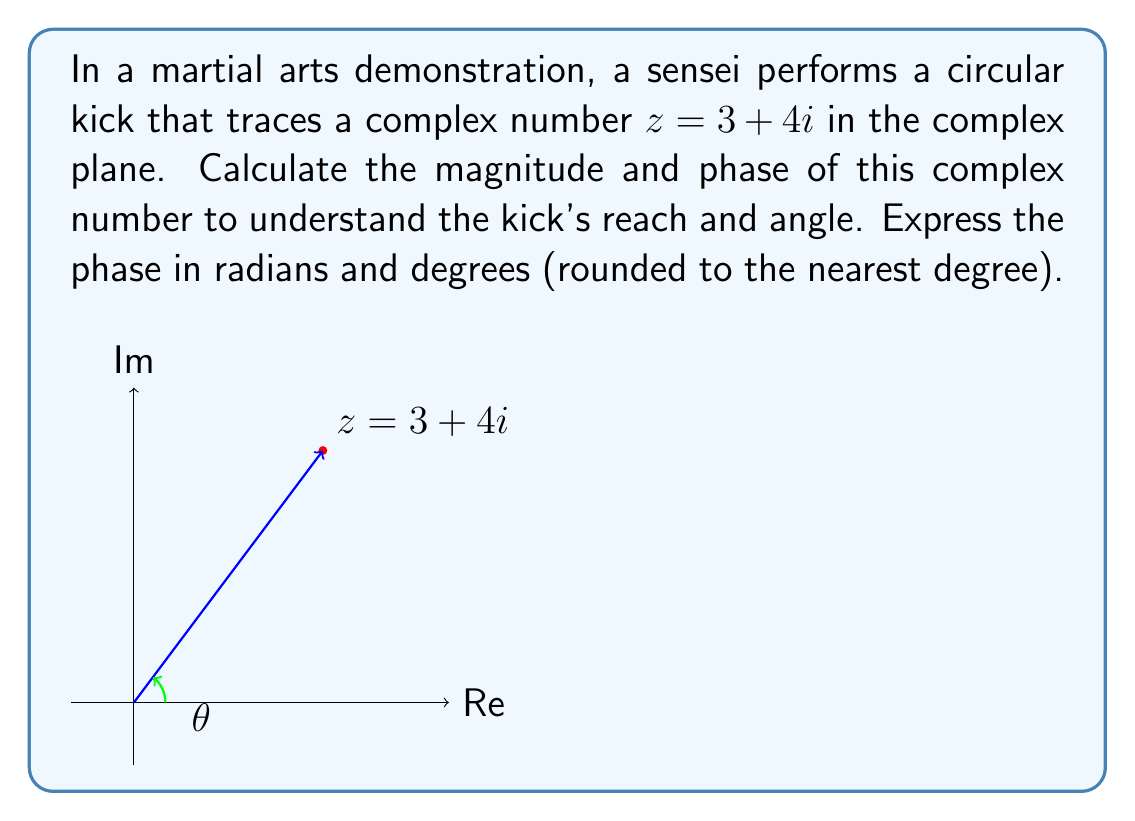Can you solve this math problem? To calculate the magnitude and phase of the complex number $z = 3 + 4i$, we follow these steps:

1. Magnitude calculation:
   The magnitude (or modulus) of a complex number $z = a + bi$ is given by $|z| = \sqrt{a^2 + b^2}$.
   $$|z| = \sqrt{3^2 + 4^2} = \sqrt{9 + 16} = \sqrt{25} = 5$$

2. Phase calculation:
   The phase (or argument) of a complex number is given by $\theta = \arctan(\frac{b}{a})$, where $a$ is the real part and $b$ is the imaginary part.
   $$\theta = \arctan(\frac{4}{3})$$

   Using a calculator or computer:
   $$\theta \approx 0.9272952180 \text{ radians}$$

   To convert radians to degrees, multiply by $\frac{180°}{\pi}$:
   $$\theta \approx 0.9272952180 \times \frac{180°}{\pi} \approx 53.13010235°$$

   Rounding to the nearest degree:
   $$\theta \approx 53°$$

The magnitude represents the reach of the kick, while the phase represents the angle of the kick relative to the horizontal axis.
Answer: Magnitude: 5, Phase: 0.9273 radians or 53° 